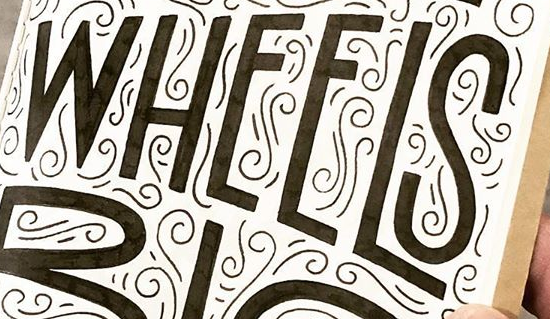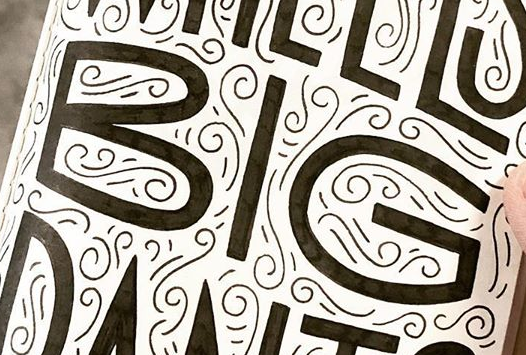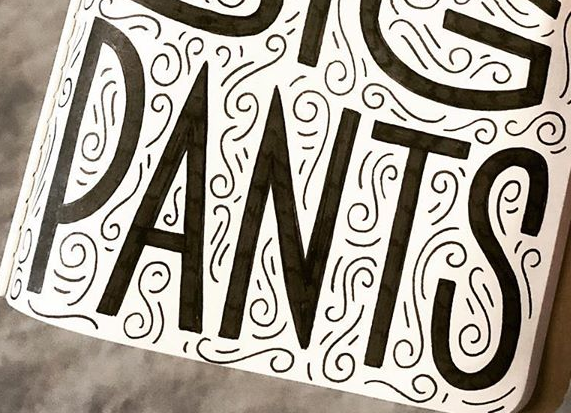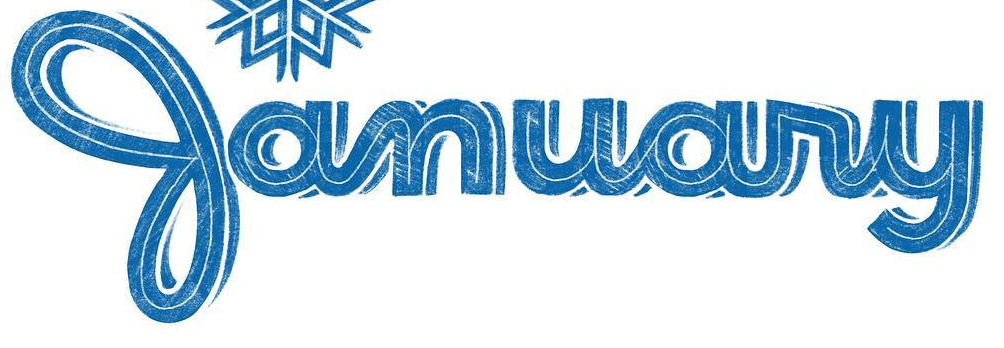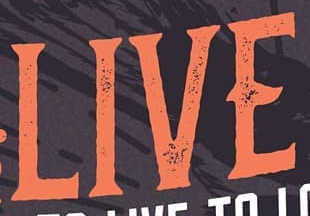Identify the words shown in these images in order, separated by a semicolon. WHEELS; BIG; PANTS; January; LIVE 